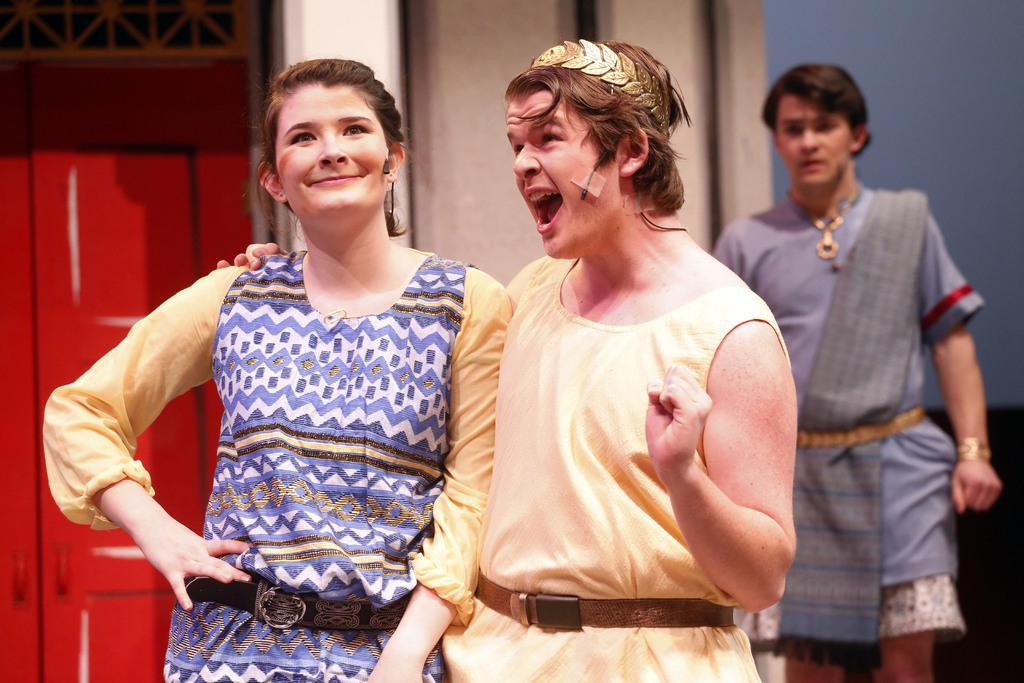Could you give a brief overview of what you see in this image? In this picture we can see three people, mics, woman smiling and in the background we can see doors, wall and some objects. 